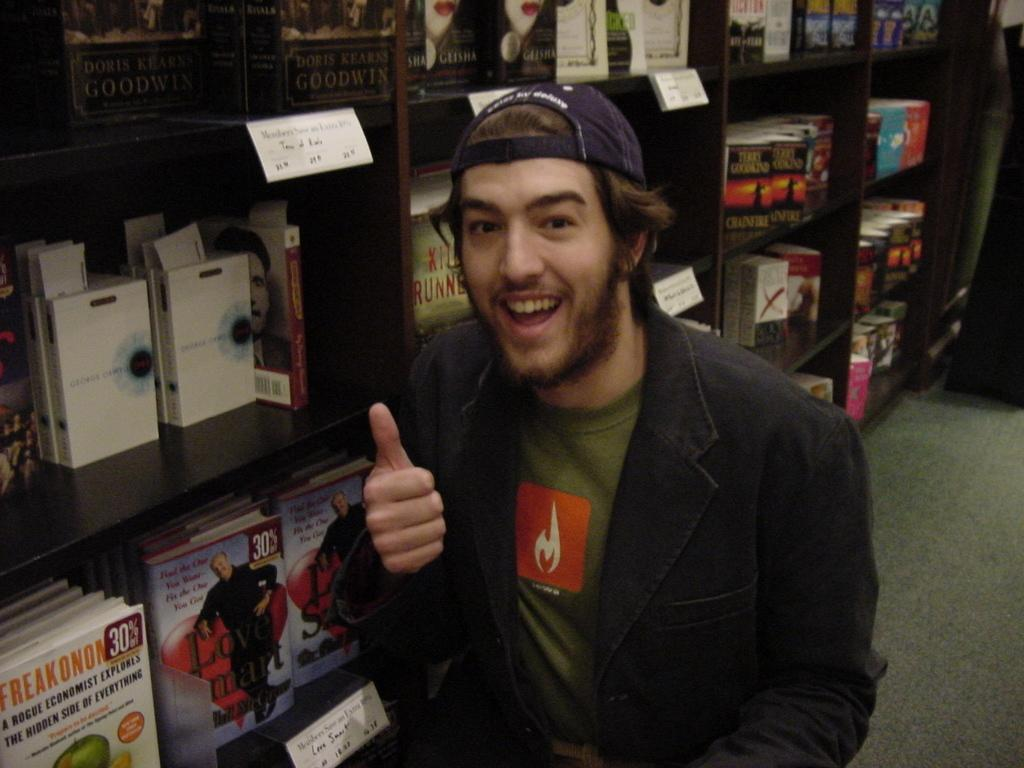Who or what is present in the image? There is a person in the image. What can be seen beneath the person? The ground is visible in the image. What type of structure is present in the image? There are shelves in the image. What is on the shelves? There are objects on the shelves. How can the objects on the shelves be identified? There are labels with text in the image. What grade of silk is used for the person's clothing in the image? There is no information about the person's clothing or the use of silk in the image. 